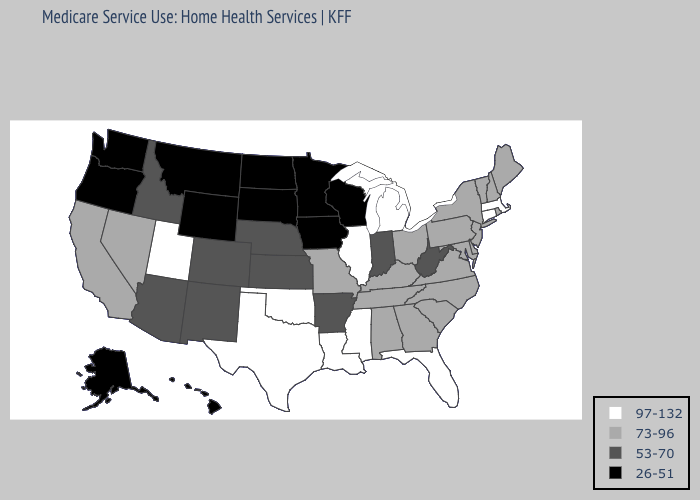What is the value of Minnesota?
Answer briefly. 26-51. Does Michigan have a higher value than Iowa?
Quick response, please. Yes. What is the lowest value in the South?
Answer briefly. 53-70. Among the states that border Oklahoma , does Texas have the lowest value?
Quick response, please. No. Which states have the highest value in the USA?
Write a very short answer. Connecticut, Florida, Illinois, Louisiana, Massachusetts, Michigan, Mississippi, Oklahoma, Texas, Utah. Among the states that border Rhode Island , which have the lowest value?
Quick response, please. Connecticut, Massachusetts. Does South Dakota have the highest value in the MidWest?
Short answer required. No. What is the value of Maryland?
Be succinct. 73-96. Does Wyoming have the lowest value in the USA?
Be succinct. Yes. Which states have the lowest value in the USA?
Keep it brief. Alaska, Hawaii, Iowa, Minnesota, Montana, North Dakota, Oregon, South Dakota, Washington, Wisconsin, Wyoming. Does Iowa have the lowest value in the USA?
Write a very short answer. Yes. What is the value of Delaware?
Write a very short answer. 73-96. Name the states that have a value in the range 53-70?
Write a very short answer. Arizona, Arkansas, Colorado, Idaho, Indiana, Kansas, Nebraska, New Mexico, West Virginia. Name the states that have a value in the range 26-51?
Give a very brief answer. Alaska, Hawaii, Iowa, Minnesota, Montana, North Dakota, Oregon, South Dakota, Washington, Wisconsin, Wyoming. What is the lowest value in states that border North Carolina?
Write a very short answer. 73-96. 